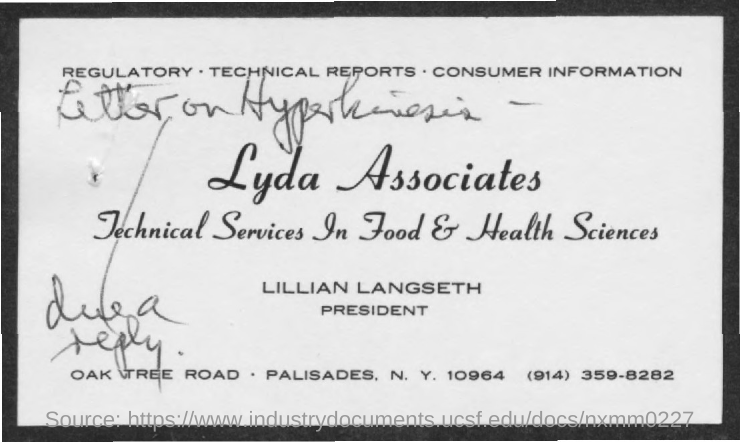Highlight a few significant elements in this photo. Lillian Langseth is the president of Lyda Associates. 